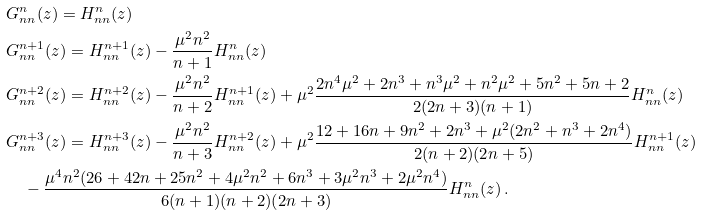<formula> <loc_0><loc_0><loc_500><loc_500>& G ^ { n } _ { n n } ( z ) = H ^ { n } _ { n n } ( z ) \\ & G ^ { n + 1 } _ { n n } ( z ) = H ^ { n + 1 } _ { n n } ( z ) - \frac { \mu ^ { 2 } n ^ { 2 } } { n + 1 } H ^ { n } _ { n n } ( z ) \\ & G ^ { n + 2 } _ { n n } ( z ) = H ^ { n + 2 } _ { n n } ( z ) - \frac { \mu ^ { 2 } n ^ { 2 } } { n + 2 } H ^ { n + 1 } _ { n n } ( z ) + \mu ^ { 2 } \frac { 2 n ^ { 4 } \mu ^ { 2 } + 2 n ^ { 3 } + n ^ { 3 } \mu ^ { 2 } + n ^ { 2 } \mu ^ { 2 } + 5 n ^ { 2 } + 5 n + 2 } { 2 ( 2 n + 3 ) ( n + 1 ) } H ^ { n } _ { n n } ( z ) \\ & G ^ { n + 3 } _ { n n } ( z ) = H ^ { n + 3 } _ { n n } ( z ) - \frac { \mu ^ { 2 } n ^ { 2 } } { n + 3 } H ^ { n + 2 } _ { n n } ( z ) + \mu ^ { 2 } \frac { 1 2 + 1 6 n + 9 n ^ { 2 } + 2 n ^ { 3 } + \mu ^ { 2 } ( 2 n ^ { 2 } + n ^ { 3 } + 2 n ^ { 4 } ) } { 2 ( n + 2 ) ( 2 n + 5 ) } H ^ { n + 1 } _ { n n } ( z ) \\ & \quad - \frac { \mu ^ { 4 } n ^ { 2 } ( 2 6 + 4 2 n + 2 5 n ^ { 2 } + 4 \mu ^ { 2 } n ^ { 2 } + 6 n ^ { 3 } + 3 \mu ^ { 2 } n ^ { 3 } + 2 \mu ^ { 2 } n ^ { 4 } ) } { 6 ( n + 1 ) ( n + 2 ) ( 2 n + 3 ) } H ^ { n } _ { n n } ( z ) \, .</formula> 